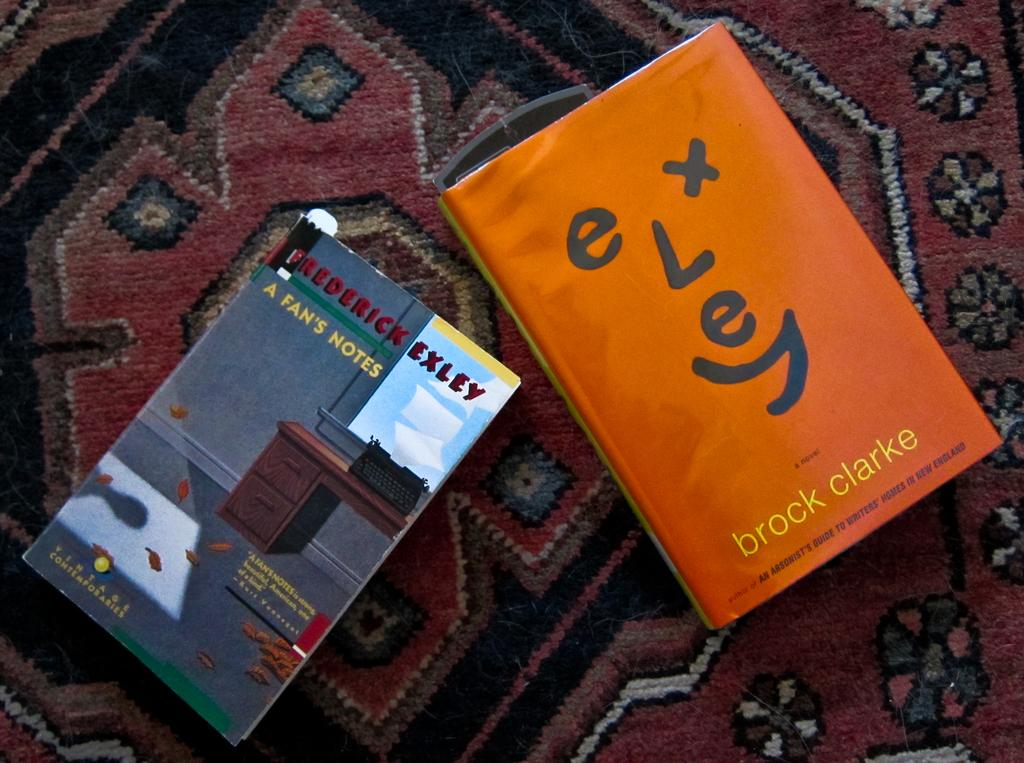Provide a one-sentence caption for the provided image. Two books sit on a carpet, one of them is written by Brock Clarke. 